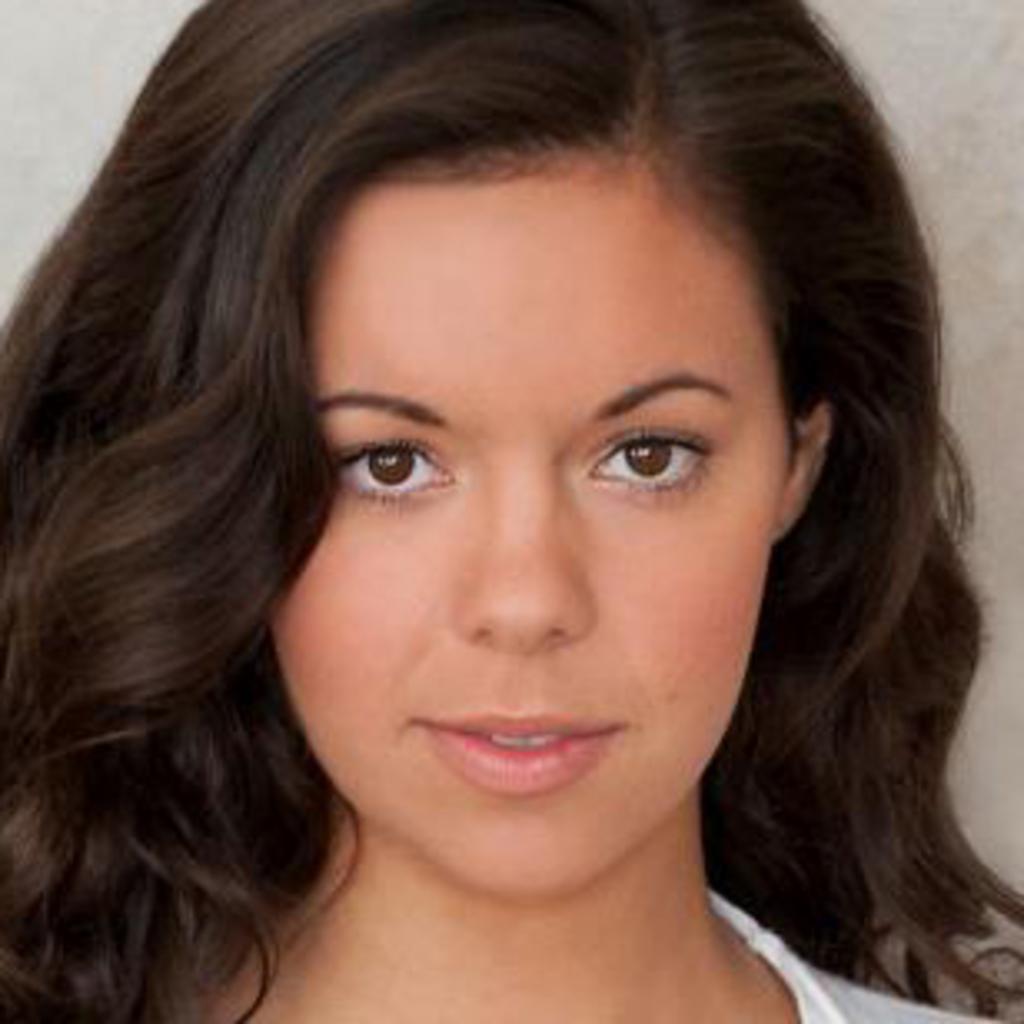In one or two sentences, can you explain what this image depicts? In this picture I can observe a woman in the middle of the picture. The background is in white color. 